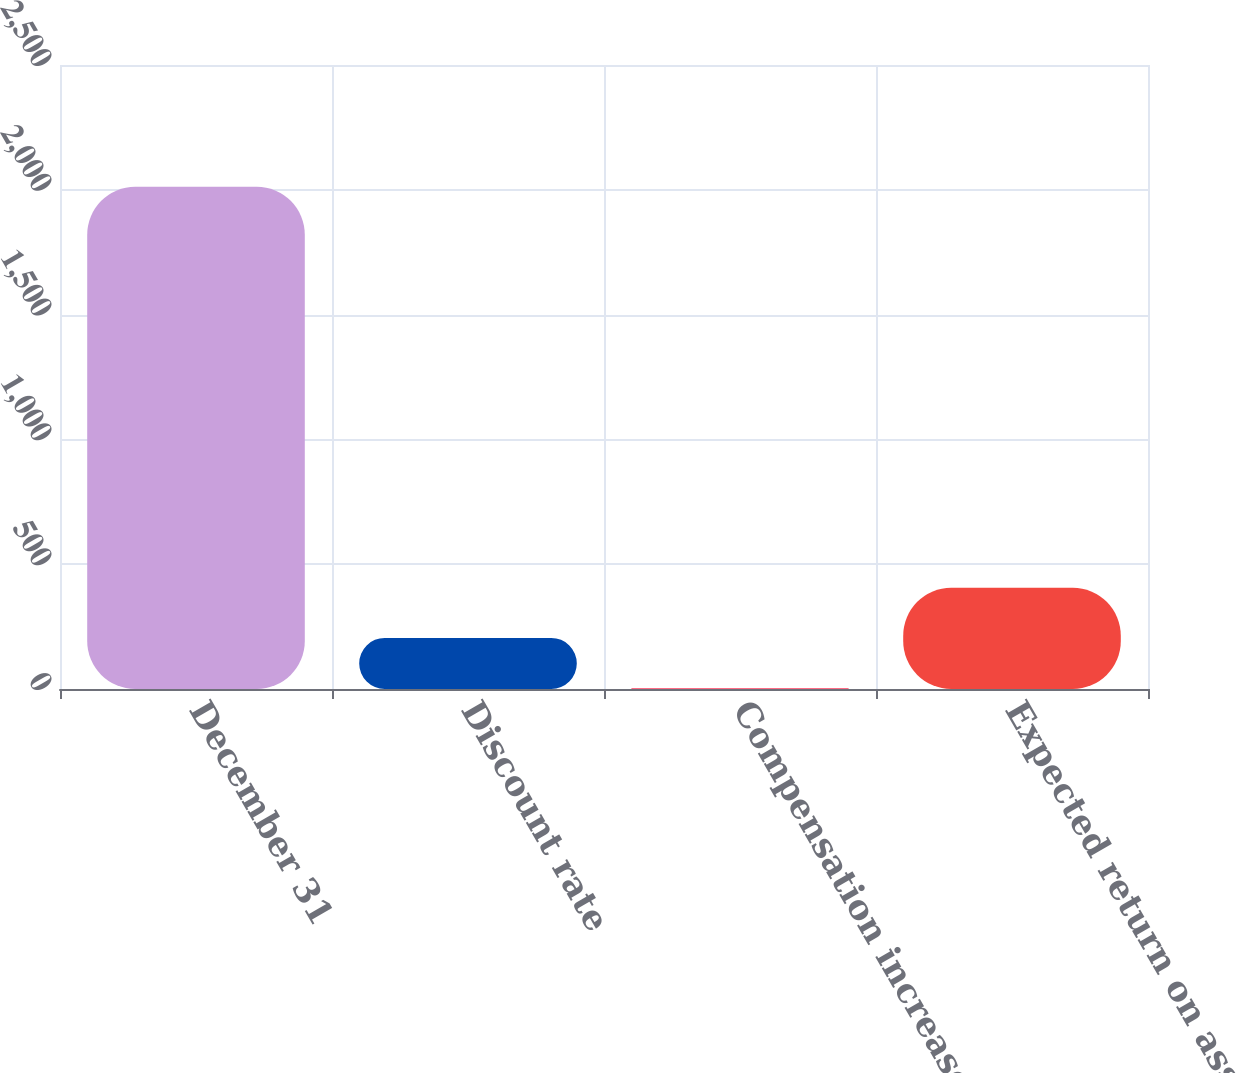Convert chart. <chart><loc_0><loc_0><loc_500><loc_500><bar_chart><fcel>December 31<fcel>Discount rate<fcel>Compensation increases<fcel>Expected return on assets<nl><fcel>2012<fcel>204.71<fcel>3.9<fcel>405.52<nl></chart> 